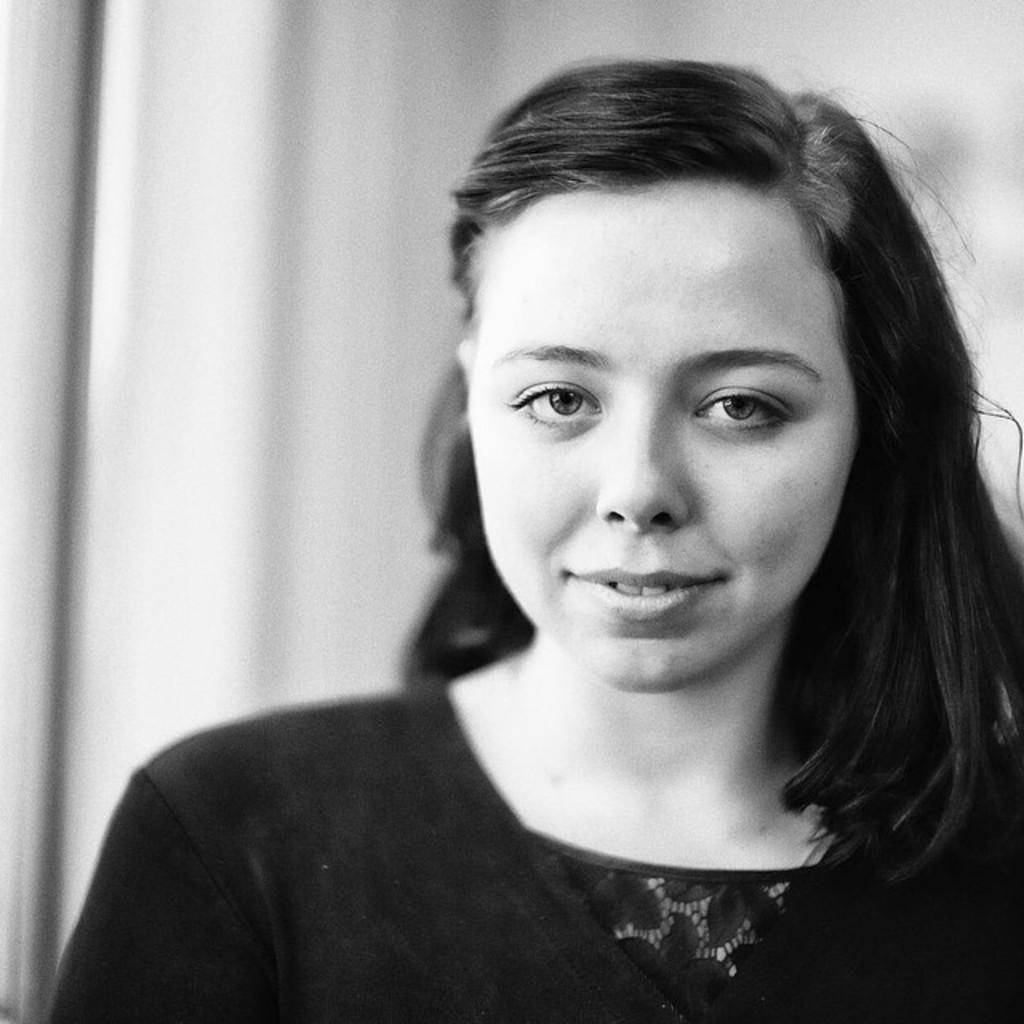Who is the main subject in the image? There is a woman in the image. What is the woman doing in the image? The woman is smiling in the image. Can you describe the background of the image? The background of the image is blurred. What is the color scheme of the image? The image is black and white. What type of thread is being used to create the bridge in the image? There is no thread or bridge present in the image; it features a woman smiling in a black and white, blurred background. 